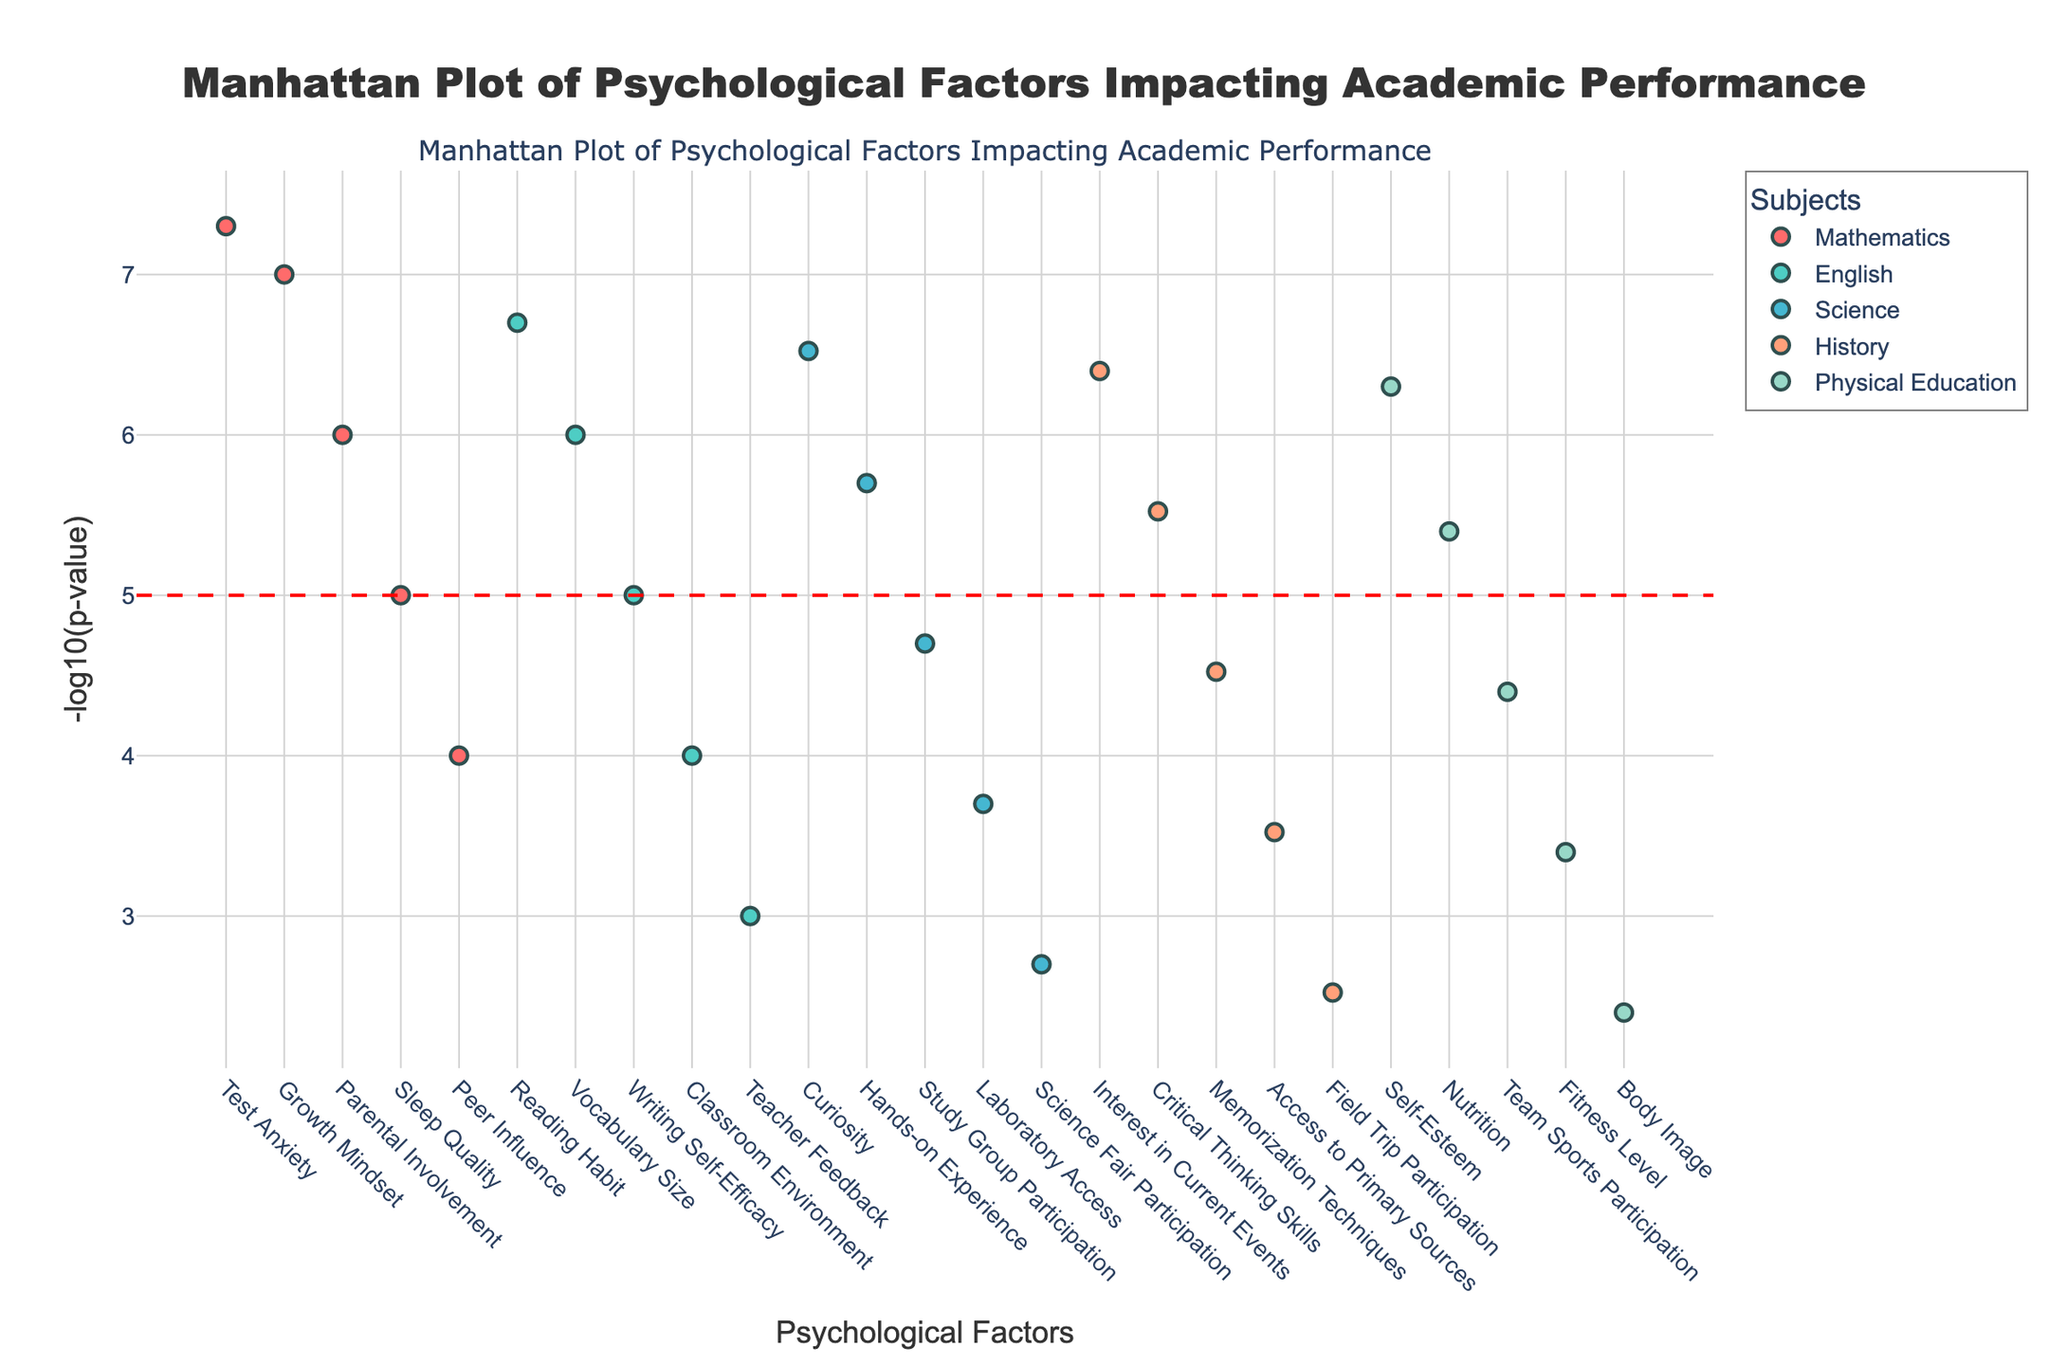what is the title of the plot? The title is usually displayed at the top of the plot and helps the viewer understand what the plot is about. According to the code, the title is set in the layout part as 'Manhattan Plot of Psychological Factors Impacting Academic Performance'.
Answer: Manhattan Plot of Psychological Factors Impacting Academic Performance How many subjects are represented in the plot? Subjects are visually indicated by different colors, and each unique subject contributes a specific color plot. The number of unique subjects can be counted from the legend that lists different subjects. In the code data, there are five unique subjects: Mathematics, English, Science, History, and Physical Education.
Answer: 5 What color represents the 'English' subject in the plot? Each subject is represented by a different color. In the color_map, 'English' is mapped to the second color in the list, which is '#4ECDC4'. This HTML color code corresponds to a shade of greenish-blue.
Answer: Greenish-blue Which psychological factor has the lowest p-value for Mathematics? The p-values are shown on the y-axis (after transformation) and can be identified by looking for the highest -log10(p-value) within each subject category. For Mathematics, the factor with the highest -log10(p-value) correspondingly will highlight the lowest p-value. Reviewing the data, Test Anxiety has the smallest p-value (0.00000005), which results in the highest -log10(p-value).
Answer: Test Anxiety How many factors have a p-value below the threshold line (-log10(p-value) > 5)? The red dashed horizontal line is placed at y = 5 to indicate the threshold. This requires counting the points in the plot with y-values greater than 5, as they indicate a higher -log10(p-value). According to the data, these factors are: Test Anxiety, Growth Mindset, Reading Habit, Curiosity, Interest in Current Events, and Self-Esteem, making the total number 6.
Answer: 6 What is the main vertical axis label? The y-axis label is defined in the layout of the plot, used to show what the axis represents. According to the given data, the y-axis represents the -log10(p-value) transformation used to highlight significant factors. The axis title in the code is '-log10(p-value)'.
Answer: -log10(p-value) Which factor has the highest association with History? The highest association is indicated by the highest -log10(p-value) for History. Reviewing the data, 'Interest in Current Events' has the highest -log10(p-value), making it the most significant factor for History in our plot.
Answer: Interest in Current Events Compare the strength of association between 'Hands-on Experience' in Science and 'Vocabulary Size' in English. Which one is more significant? To compare the strength of associations, check the -log10(p-value). Higher values indicate stronger associations. From the data, Hands-on Experience in Science has a -log10(p-value) of -log10(0.000002), and Vocabulary Size in English has -log10(0.000001). Evaluating -log10(0.000002) vs. -log10(0.000001) shows that Vocabulary Size in English (log10(p)=6) is more significant than Hands-on Experience in Science (-log10(p)=5.69897).
Answer: Vocabulary Size in English What is the primary color used for plotting 'Mathematics'? Each subject is assigned a unique color. The color_map matches 'Mathematics' to the first color in its definition, which is '#FF6B6B'. In visual representation, it appears as a shade of red.
Answer: Red What is the highest -log10(p-value) across all subjects and factors? The peak -log10(p-value) represents the factor with the smallest p-value across all subjects. By examining the data, the smallest p-value is 0.00000005 for Test Anxiety in Mathematics, resulting in the highest -log10(p-value) of -log10(0.00000005), equating to approximately 7.301.
Answer: 7.301 